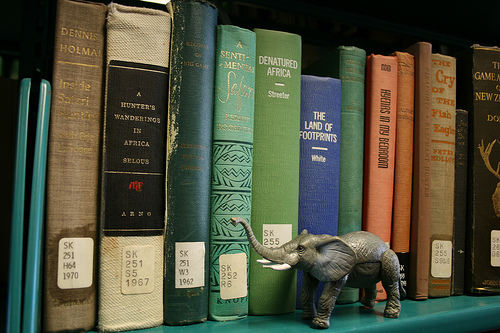<image>
Is the book behind the elephant? Yes. From this viewpoint, the book is positioned behind the elephant, with the elephant partially or fully occluding the book. 